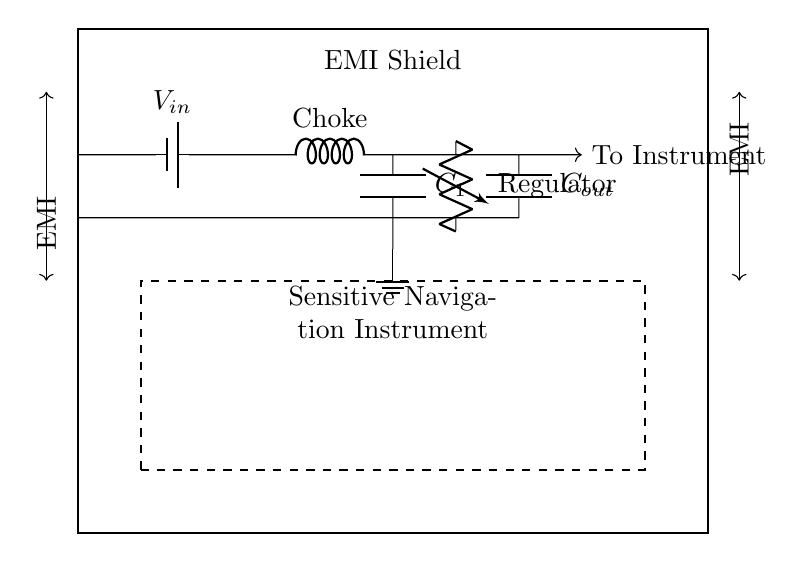What component is used for filtering in this circuit? The component used for filtering is a choke, which is indicated by the label in the circuit diagram. It is shown connected to the input voltage and is typically used to block high-frequency noise while allowing DC signals to pass.
Answer: Choke What kind of power supply is utilized in this circuit? The circuit uses a battery as the power supply, which is represented in the diagram. Its symbol typically denotes a source of electrical energy, with a positive and negative terminal.
Answer: Battery What role does the output capacitor play in this circuit? The output capacitor, labeled as C out, is used to smooth out voltage fluctuations and provide a stable output voltage. It helps in reducing noise and ensuring that the sensitive navigation instrument receives a clean power supply.
Answer: Voltage smoothing How many EMI arrows are depicted in the diagram, and what do they indicate? There are two EMI arrows depicted, one on each side of the shield, indicating that the shield is protecting against electromagnetic interference from both directions. This highlights the effectiveness of the EMI shielding in this circuit.
Answer: Two What is the purpose of the voltage regulator in this configuration? The voltage regulator ensures that the voltage supplied to the sensitive navigation instrument remains constant, despite any fluctuations in the input voltage or load conditions. It stabilizes the output, which is crucial for maintaining the performance of sensitive electronics.
Answer: Voltage stabilization What does the dashed rectangle in the middle of the diagram represent? The dashed rectangle represents the sensitive navigation instrument, indicating the area that requires protection from EMI. This visualization highlights that the instrument is crucial and must be shielded for proper operation.
Answer: Sensitive navigation instrument What is the significance of the EMI shield around the navigation instrument? The EMI shield serves to protect the sensitive navigation instrument from external electromagnetic interference, ensuring that the signals used for navigation are not distorted or disrupted by external noise sources. This is critical for the instrument's reliability and accuracy.
Answer: Protection against EMI 